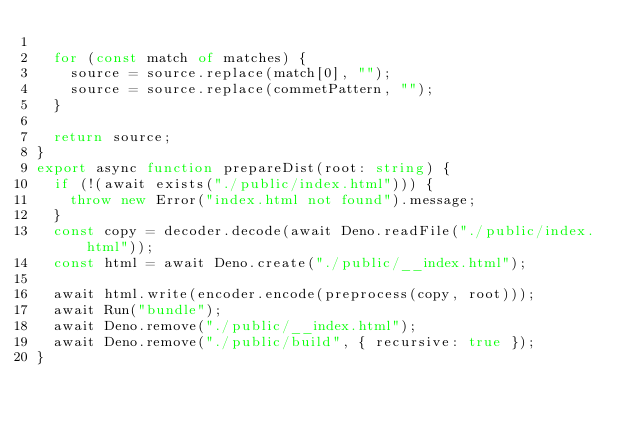<code> <loc_0><loc_0><loc_500><loc_500><_TypeScript_>
  for (const match of matches) {
    source = source.replace(match[0], "");
    source = source.replace(commetPattern, "");
  }

  return source;
}
export async function prepareDist(root: string) {
  if (!(await exists("./public/index.html"))) {
    throw new Error("index.html not found").message;
  }
  const copy = decoder.decode(await Deno.readFile("./public/index.html"));
  const html = await Deno.create("./public/__index.html");

  await html.write(encoder.encode(preprocess(copy, root)));
  await Run("bundle");
  await Deno.remove("./public/__index.html");
  await Deno.remove("./public/build", { recursive: true });
}
</code> 